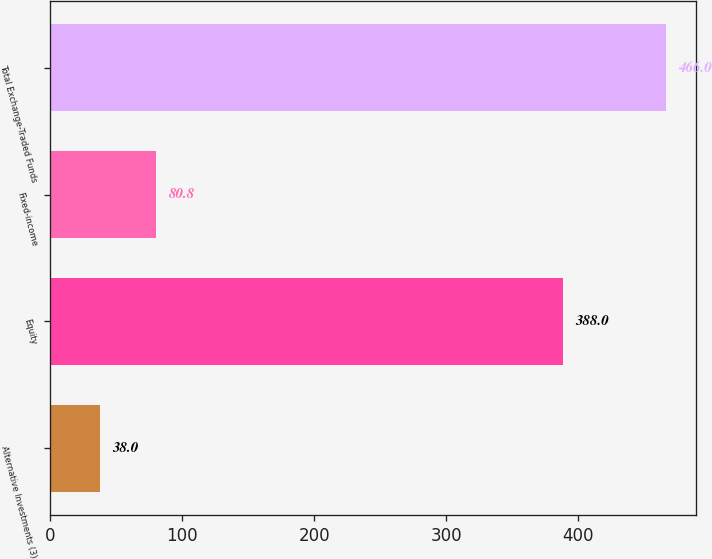<chart> <loc_0><loc_0><loc_500><loc_500><bar_chart><fcel>Alternative Investments (3)<fcel>Equity<fcel>Fixed-income<fcel>Total Exchange-Traded Funds<nl><fcel>38<fcel>388<fcel>80.8<fcel>466<nl></chart> 